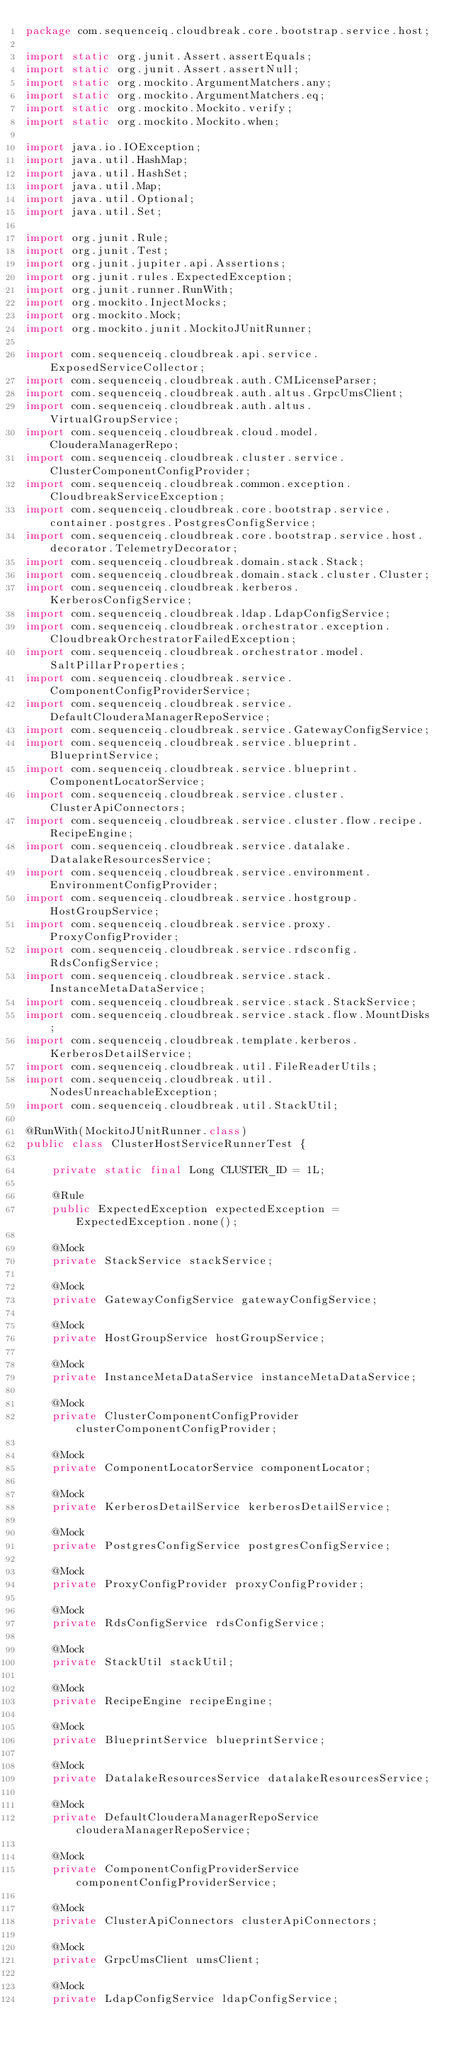Convert code to text. <code><loc_0><loc_0><loc_500><loc_500><_Java_>package com.sequenceiq.cloudbreak.core.bootstrap.service.host;

import static org.junit.Assert.assertEquals;
import static org.junit.Assert.assertNull;
import static org.mockito.ArgumentMatchers.any;
import static org.mockito.ArgumentMatchers.eq;
import static org.mockito.Mockito.verify;
import static org.mockito.Mockito.when;

import java.io.IOException;
import java.util.HashMap;
import java.util.HashSet;
import java.util.Map;
import java.util.Optional;
import java.util.Set;

import org.junit.Rule;
import org.junit.Test;
import org.junit.jupiter.api.Assertions;
import org.junit.rules.ExpectedException;
import org.junit.runner.RunWith;
import org.mockito.InjectMocks;
import org.mockito.Mock;
import org.mockito.junit.MockitoJUnitRunner;

import com.sequenceiq.cloudbreak.api.service.ExposedServiceCollector;
import com.sequenceiq.cloudbreak.auth.CMLicenseParser;
import com.sequenceiq.cloudbreak.auth.altus.GrpcUmsClient;
import com.sequenceiq.cloudbreak.auth.altus.VirtualGroupService;
import com.sequenceiq.cloudbreak.cloud.model.ClouderaManagerRepo;
import com.sequenceiq.cloudbreak.cluster.service.ClusterComponentConfigProvider;
import com.sequenceiq.cloudbreak.common.exception.CloudbreakServiceException;
import com.sequenceiq.cloudbreak.core.bootstrap.service.container.postgres.PostgresConfigService;
import com.sequenceiq.cloudbreak.core.bootstrap.service.host.decorator.TelemetryDecorator;
import com.sequenceiq.cloudbreak.domain.stack.Stack;
import com.sequenceiq.cloudbreak.domain.stack.cluster.Cluster;
import com.sequenceiq.cloudbreak.kerberos.KerberosConfigService;
import com.sequenceiq.cloudbreak.ldap.LdapConfigService;
import com.sequenceiq.cloudbreak.orchestrator.exception.CloudbreakOrchestratorFailedException;
import com.sequenceiq.cloudbreak.orchestrator.model.SaltPillarProperties;
import com.sequenceiq.cloudbreak.service.ComponentConfigProviderService;
import com.sequenceiq.cloudbreak.service.DefaultClouderaManagerRepoService;
import com.sequenceiq.cloudbreak.service.GatewayConfigService;
import com.sequenceiq.cloudbreak.service.blueprint.BlueprintService;
import com.sequenceiq.cloudbreak.service.blueprint.ComponentLocatorService;
import com.sequenceiq.cloudbreak.service.cluster.ClusterApiConnectors;
import com.sequenceiq.cloudbreak.service.cluster.flow.recipe.RecipeEngine;
import com.sequenceiq.cloudbreak.service.datalake.DatalakeResourcesService;
import com.sequenceiq.cloudbreak.service.environment.EnvironmentConfigProvider;
import com.sequenceiq.cloudbreak.service.hostgroup.HostGroupService;
import com.sequenceiq.cloudbreak.service.proxy.ProxyConfigProvider;
import com.sequenceiq.cloudbreak.service.rdsconfig.RdsConfigService;
import com.sequenceiq.cloudbreak.service.stack.InstanceMetaDataService;
import com.sequenceiq.cloudbreak.service.stack.StackService;
import com.sequenceiq.cloudbreak.service.stack.flow.MountDisks;
import com.sequenceiq.cloudbreak.template.kerberos.KerberosDetailService;
import com.sequenceiq.cloudbreak.util.FileReaderUtils;
import com.sequenceiq.cloudbreak.util.NodesUnreachableException;
import com.sequenceiq.cloudbreak.util.StackUtil;

@RunWith(MockitoJUnitRunner.class)
public class ClusterHostServiceRunnerTest {

    private static final Long CLUSTER_ID = 1L;

    @Rule
    public ExpectedException expectedException = ExpectedException.none();

    @Mock
    private StackService stackService;

    @Mock
    private GatewayConfigService gatewayConfigService;

    @Mock
    private HostGroupService hostGroupService;

    @Mock
    private InstanceMetaDataService instanceMetaDataService;

    @Mock
    private ClusterComponentConfigProvider clusterComponentConfigProvider;

    @Mock
    private ComponentLocatorService componentLocator;

    @Mock
    private KerberosDetailService kerberosDetailService;

    @Mock
    private PostgresConfigService postgresConfigService;

    @Mock
    private ProxyConfigProvider proxyConfigProvider;

    @Mock
    private RdsConfigService rdsConfigService;

    @Mock
    private StackUtil stackUtil;

    @Mock
    private RecipeEngine recipeEngine;

    @Mock
    private BlueprintService blueprintService;

    @Mock
    private DatalakeResourcesService datalakeResourcesService;

    @Mock
    private DefaultClouderaManagerRepoService clouderaManagerRepoService;

    @Mock
    private ComponentConfigProviderService componentConfigProviderService;

    @Mock
    private ClusterApiConnectors clusterApiConnectors;

    @Mock
    private GrpcUmsClient umsClient;

    @Mock
    private LdapConfigService ldapConfigService;
</code> 